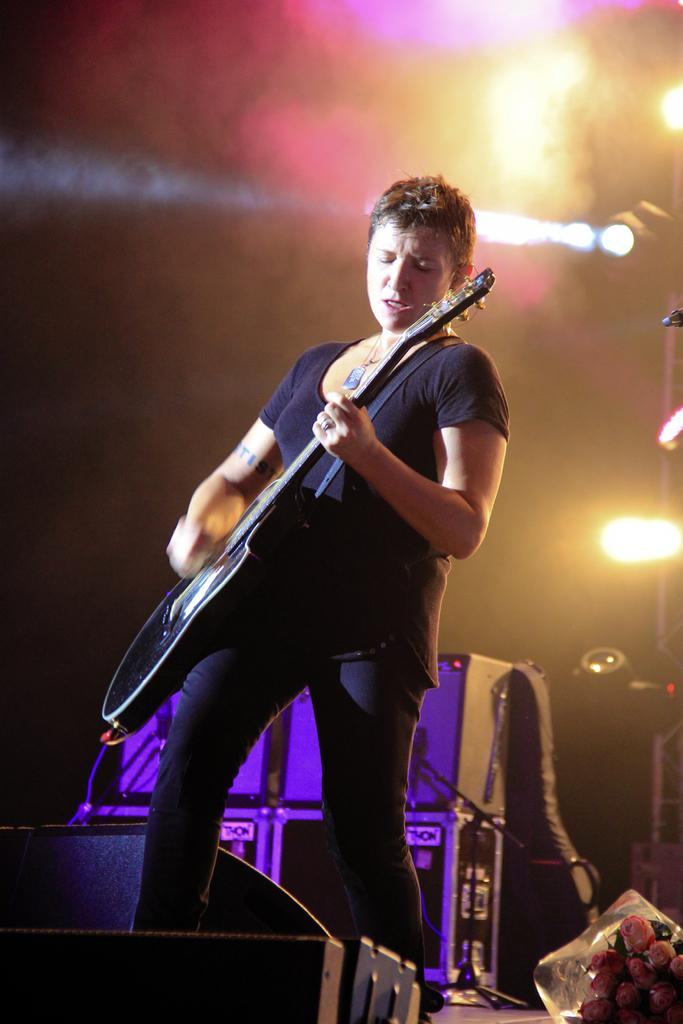What is the main subject of the image? The main subject of the image is a man standing in the middle. What is the man holding in the image? The man is holding a guitar. What else can be seen in the image besides the man and his guitar? There are musical devices behind the man and lights visible at the top of the image. What type of lettuce is being used as a prop in the image? There is no lettuce present in the image. 